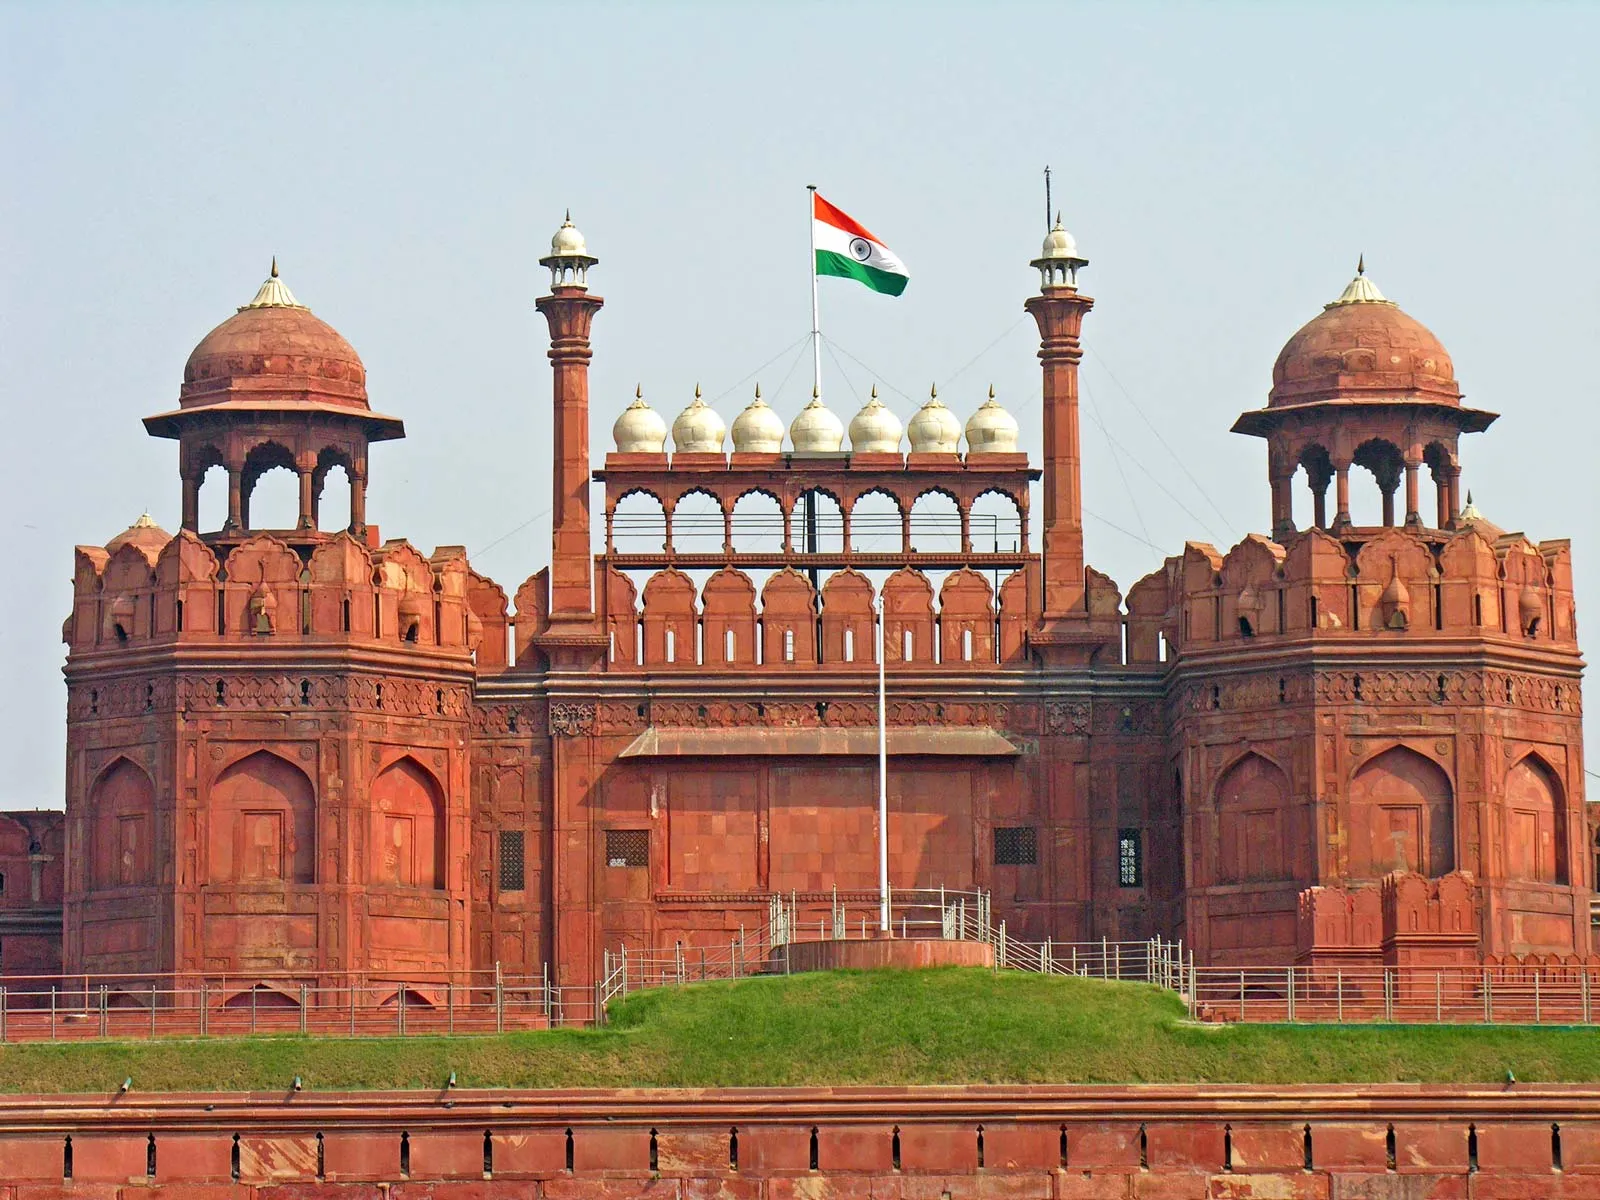Can you describe a specific event or festival celebrated at this site? One of the most significant events celebrated at the Red Fort is India's Independence Day on August 15th. Each year, the Prime Minister hoists the national flag and delivers a speech from the ramparts of the fort, addressing the nation. This event is marked by a grand ceremony with parades, cultural performances, and widespread national participation. The fort is adorned with lights and decorations, creating a festive and patriotic atmosphere. It serves as a reminder of India's struggle for independence and its ongoing journey as a sovereign nation. 